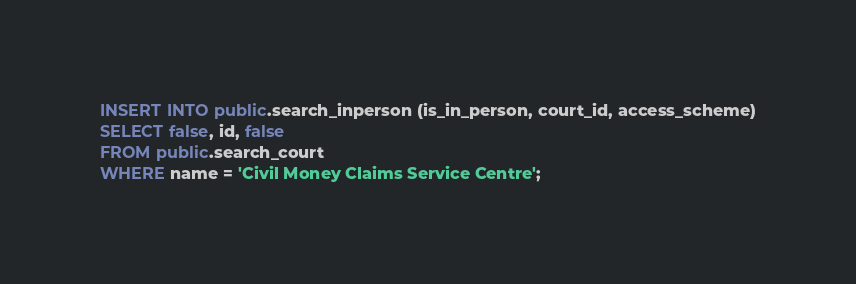Convert code to text. <code><loc_0><loc_0><loc_500><loc_500><_SQL_>INSERT INTO public.search_inperson (is_in_person, court_id, access_scheme)
SELECT false, id, false
FROM public.search_court
WHERE name = 'Civil Money Claims Service Centre';
</code> 